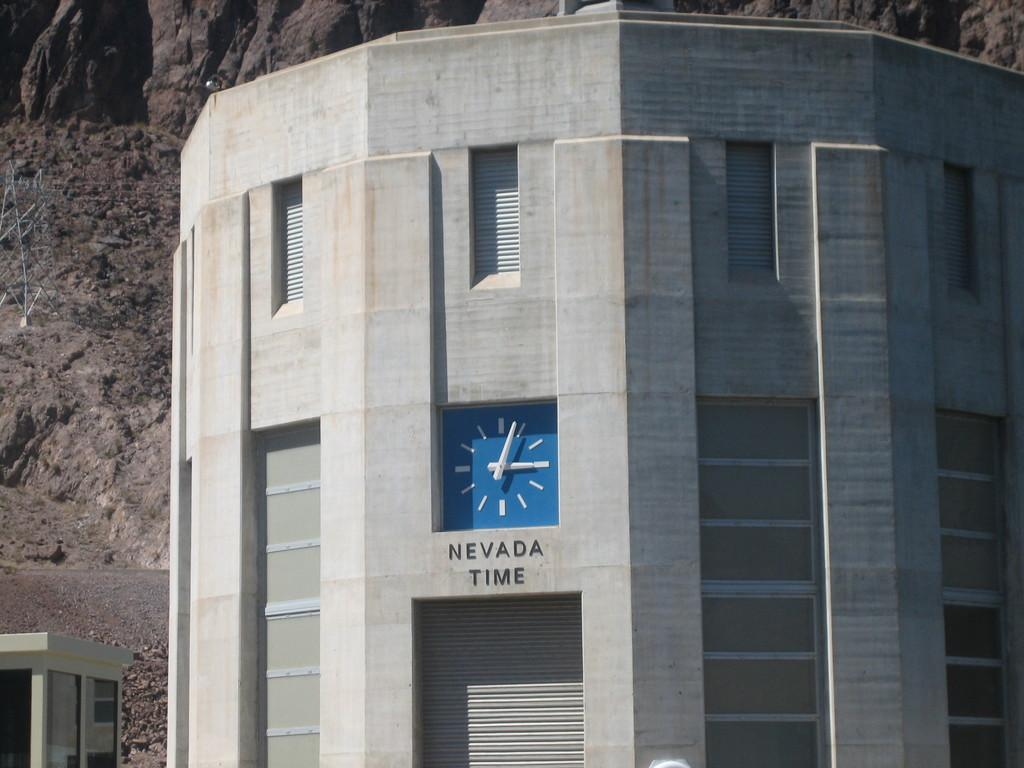<image>
Write a terse but informative summary of the picture. a building with a clock on the outside explaining it is Nevada Time. 